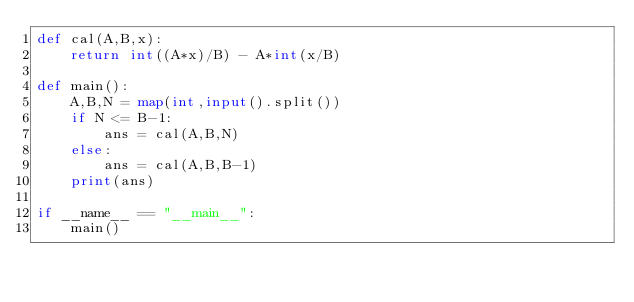<code> <loc_0><loc_0><loc_500><loc_500><_Python_>def cal(A,B,x):
    return int((A*x)/B) - A*int(x/B)

def main():
    A,B,N = map(int,input().split())
    if N <= B-1:
        ans = cal(A,B,N)
    else:
        ans = cal(A,B,B-1)
    print(ans)

if __name__ == "__main__":
    main()
</code> 